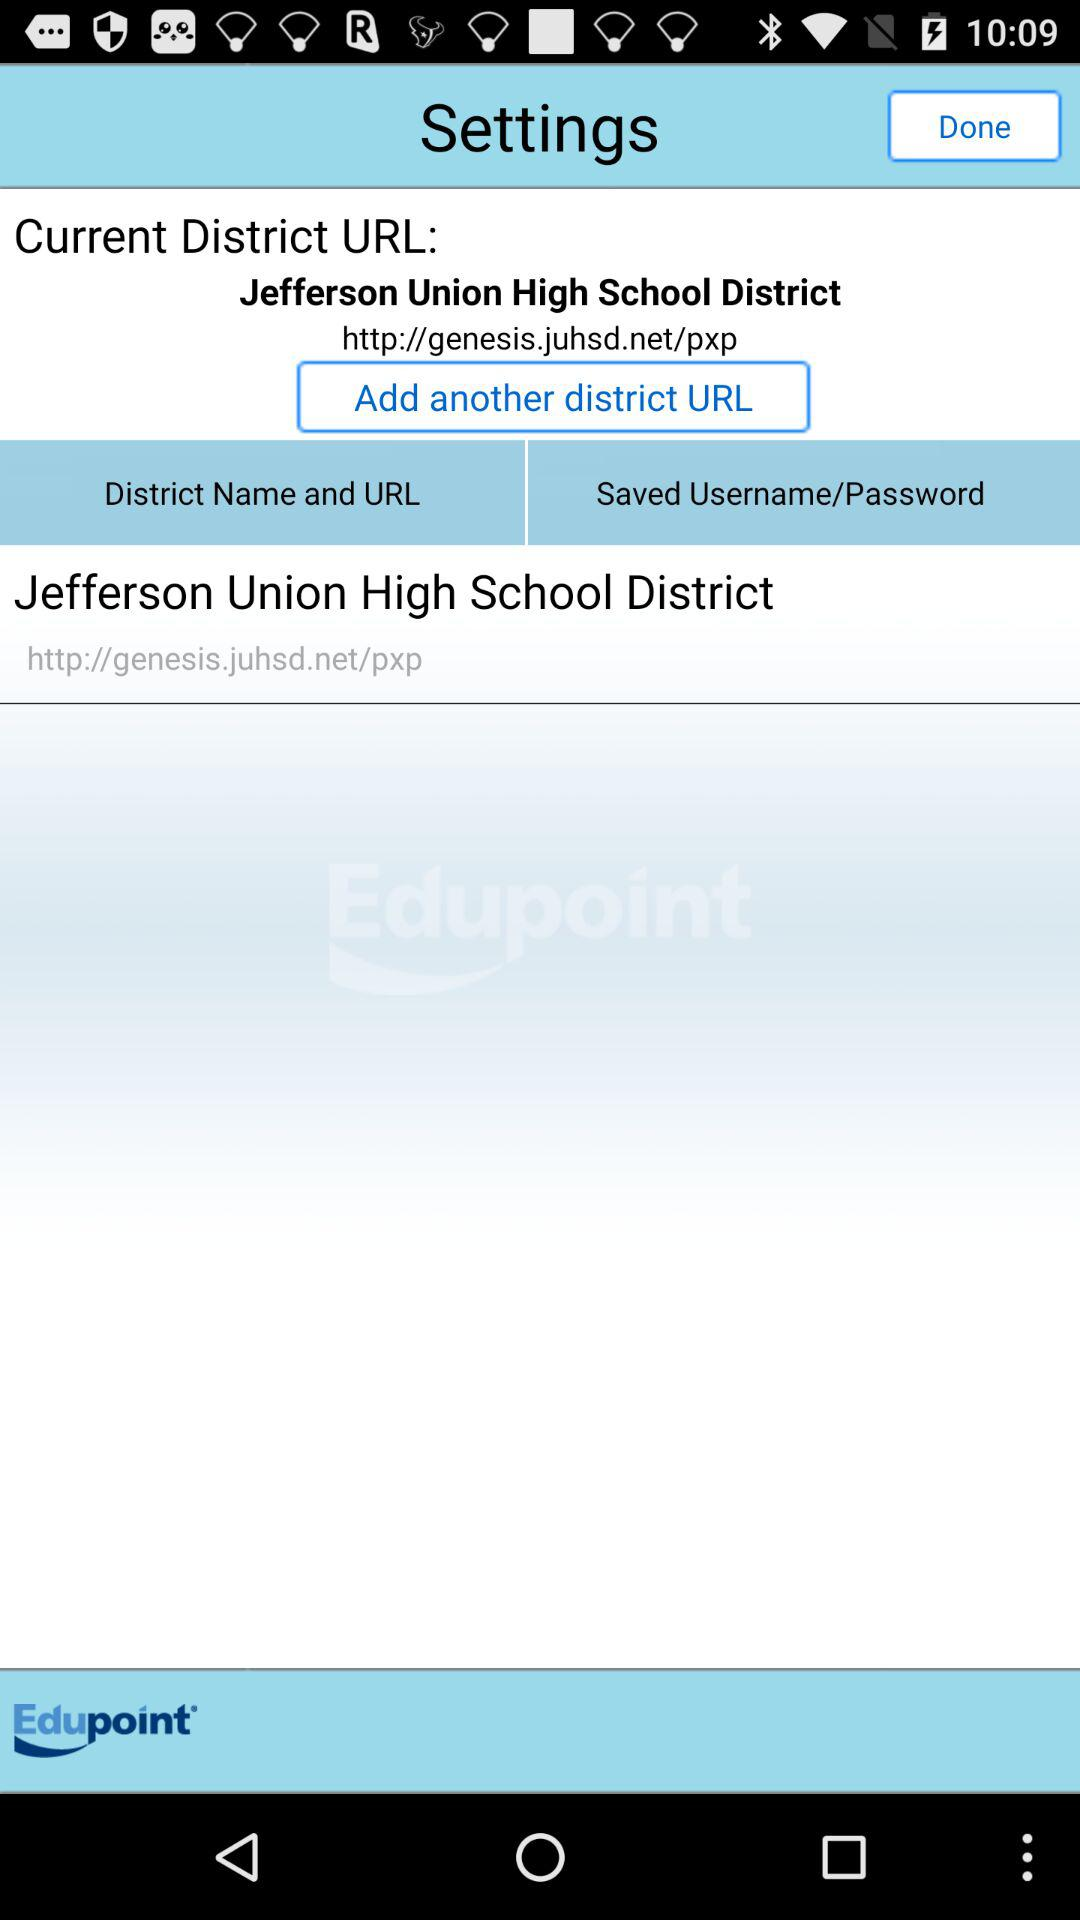What is the current district's URL address? The current district's URL address is http://genesis.juhsd.net/pxp. 